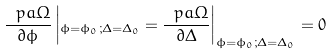Convert formula to latex. <formula><loc_0><loc_0><loc_500><loc_500>\frac { \ p a \Omega } { \partial \phi } \left | _ { \phi = \phi _ { 0 } ; \Delta = \Delta _ { 0 } } = \frac { \ p a \Omega } { \partial \Delta } \right | _ { \phi = \phi _ { 0 } ; \Delta = \Delta _ { 0 } } = 0 \</formula> 